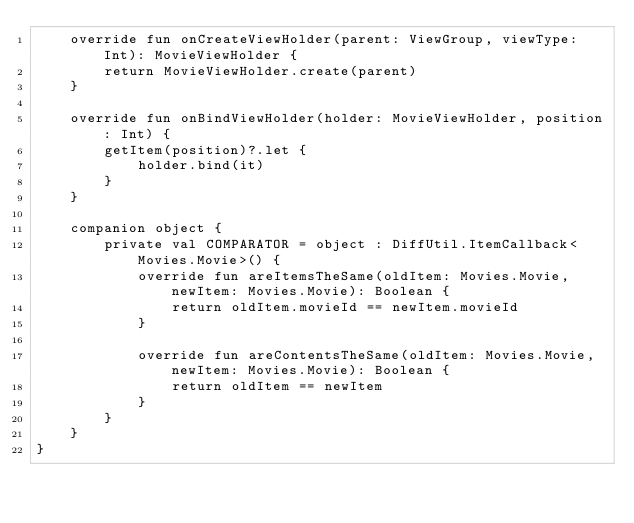Convert code to text. <code><loc_0><loc_0><loc_500><loc_500><_Kotlin_>    override fun onCreateViewHolder(parent: ViewGroup, viewType: Int): MovieViewHolder {
        return MovieViewHolder.create(parent)
    }

    override fun onBindViewHolder(holder: MovieViewHolder, position: Int) {
        getItem(position)?.let {
            holder.bind(it)
        }
    }

    companion object {
        private val COMPARATOR = object : DiffUtil.ItemCallback<Movies.Movie>() {
            override fun areItemsTheSame(oldItem: Movies.Movie, newItem: Movies.Movie): Boolean {
                return oldItem.movieId == newItem.movieId
            }

            override fun areContentsTheSame(oldItem: Movies.Movie, newItem: Movies.Movie): Boolean {
                return oldItem == newItem
            }
        }
    }
}
</code> 